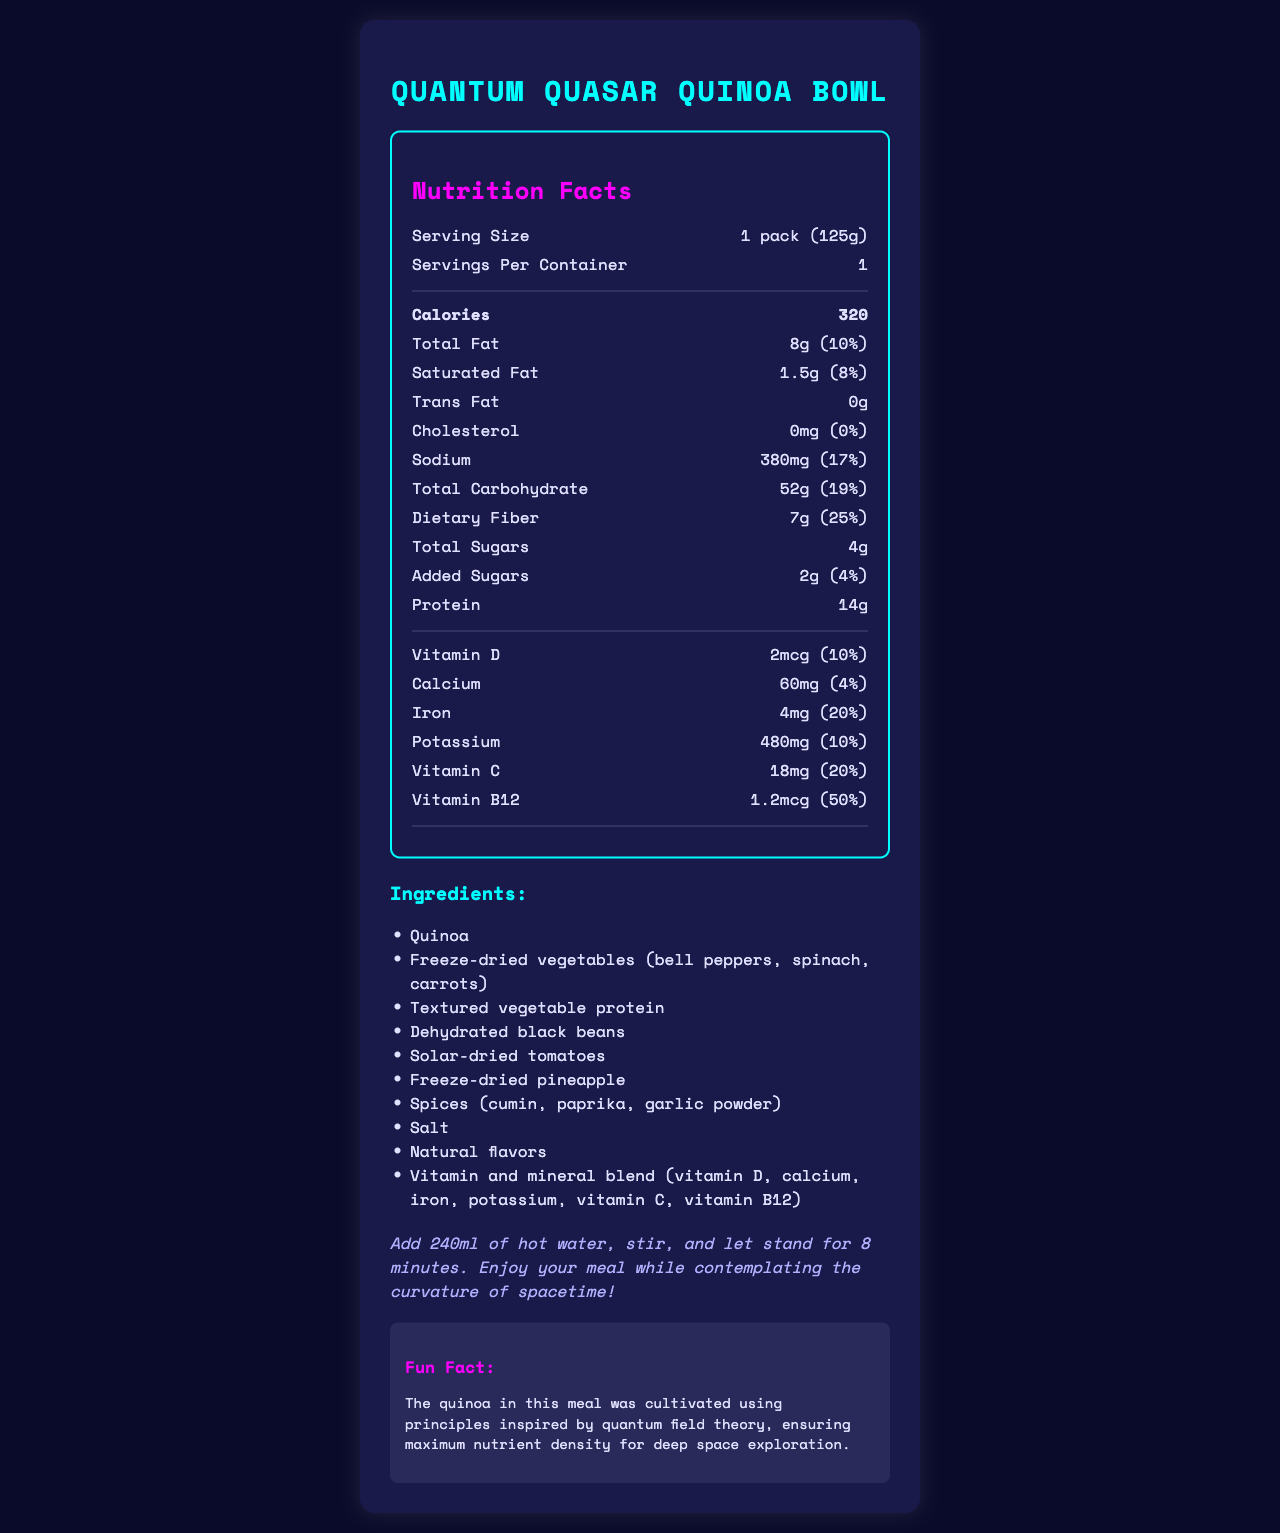what is the serving size of the Quantum Quasar Quinoa Bowl? According to the document, the serving size is listed as "1 pack (125g)".
Answer: 1 pack (125g) how many calories are in one serving of the Quantum Quasar Quinoa Bowl? The document states that each serving contains 320 calories.
Answer: 320 what kind of fats are present in the Quantum Quasar Quinoa Bowl, and what are their amounts? The total fat is 8g, saturated fat is 1.5g, and trans fat is 0g as listed in the nutrition section of the document.
Answer: Total Fat: 8g, Saturated Fat: 1.5g, Trans Fat: 0g how much dietary fiber does the Quantum Quasar Quinoa Bowl provide per serving? The document lists that each serving contains 7g of dietary fiber.
Answer: 7g what is the shelf life of the Quantum Quasar Quinoa Bowl? The document mentions a shelf life of 5 years when stored at room temperature.
Answer: 5 years when stored at room temperature how much sodium is in a serving of the Quantum Quasar Quinoa Bowl? The nutrition label shows that a serving contains 380mg of sodium.
Answer: 380mg which vitamins and minerals are included in the Quantum Quasar Quinoa Bowl, and what are their amounts per serving? The document lists the amounts of Vitamin D, Calcium, Iron, Potassium, Vitamin C, and Vitamin B12 per serving.
Answer: Vitamin D: 2mcg, Calcium: 60mg, Iron: 4mg, Potassium: 480mg, Vitamin C: 18mg, Vitamin B12: 1.2mcg which of the following ingredients is not listed as part of the Quantum Quasar Quinoa Bowl? A. Freeze-dried vegetables B. Textured vegetable protein C. Dehydrated chicken The listed ingredients include freeze-dried vegetables and textured vegetable protein but do not mention dehydrated chicken.
Answer: C. Dehydrated chicken what is the daily value percentage for iron in the Quantum Quasar Quinoa Bowl? The document notes that the daily value percentage for iron is 20%.
Answer: 20% is the Quantum Quasar Quinoa Bowl free from common allergens? The document states "Contains: None" under allergen information, indicating it's free from common allergens.
Answer: Yes which statement best describes the fun fact about the Quantum Quasar Quinoa Bowl? A. The meal pack was designed using space technology B. The quinoa was cultivated using principles inspired by quantum field theory C. The meal is safe for astronauts to eat on long-duration missions The fun fact in the document says the quinoa was cultivated using principles inspired by quantum field theory.
Answer: B. The quinoa was cultivated using principles inspired by quantum field theory describe how to prepare the Quantum Quasar Quinoa Bowl. The preparation instructions are given as adding 240ml of hot water, stirring, and letting it stand for 8 minutes with a whimsical note on enjoying the meal.
Answer: Add 240ml of hot water, stir, and let stand for 8 minutes. Enjoy your meal while contemplating the curvature of spacetime! does the Quantum Quasar Quinoa Bowl contain any added sugars? It contains 2g of added sugars as indicated in the nutrition facts.
Answer: Yes summarize the main idea of the document. The document is a comprehensive nutritional breakdown and preparation guide for a specialized astronaut meal with an emphasis on its space-related design and nutrient density.
Answer: The Quantum Quasar Quinoa Bowl is a freeze-dried astronaut meal pack designed for long-duration space missions. It contains 320 calories per serving, with detailed nutritional information listed, including total fat, sodium, carbohydrates, dietary fiber, sugars, and protein, as well as vitamins and minerals. The meal is allergen-free, with a 5-year shelf life and easy preparation instructions. The ingredients reflect a focus on nutrient density, and a fun fact highlights the quinoa's cultivation inspired by quantum field theory. what colors are used in the design of the document? The colors of the document design are not described in the provided data.
Answer: Cannot be determined 